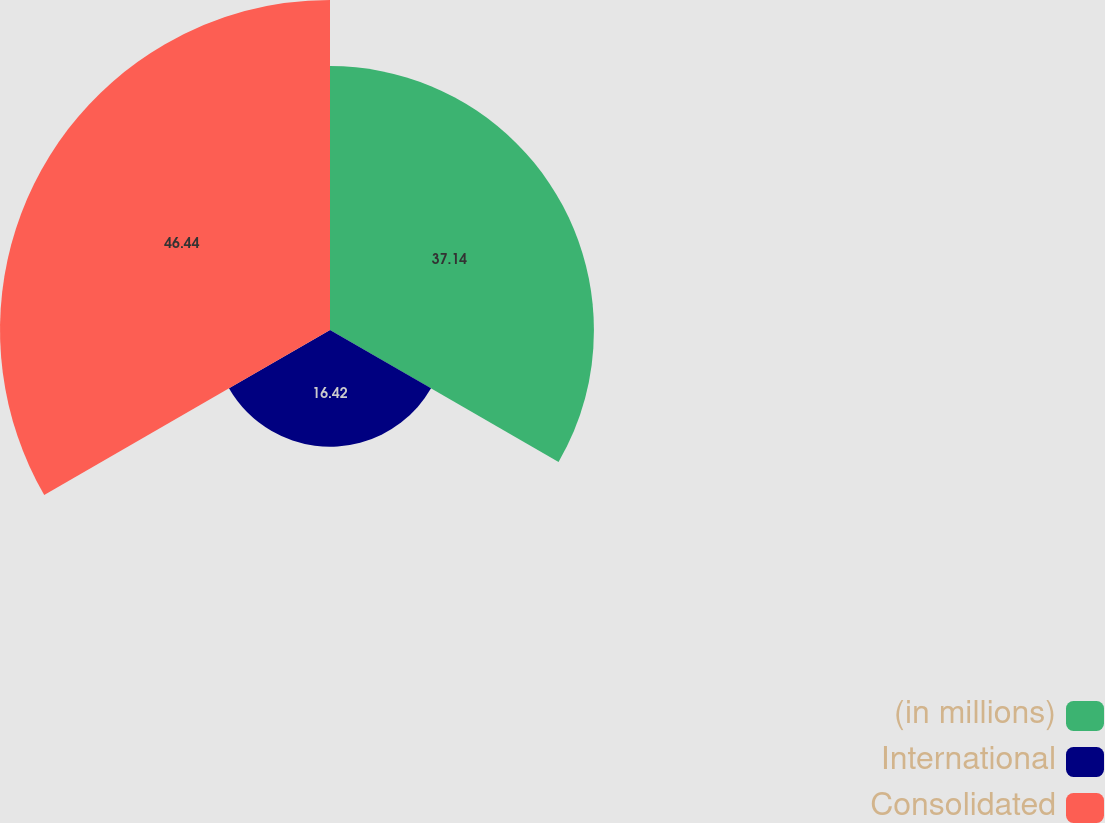<chart> <loc_0><loc_0><loc_500><loc_500><pie_chart><fcel>(in millions)<fcel>International<fcel>Consolidated<nl><fcel>37.14%<fcel>16.42%<fcel>46.44%<nl></chart> 